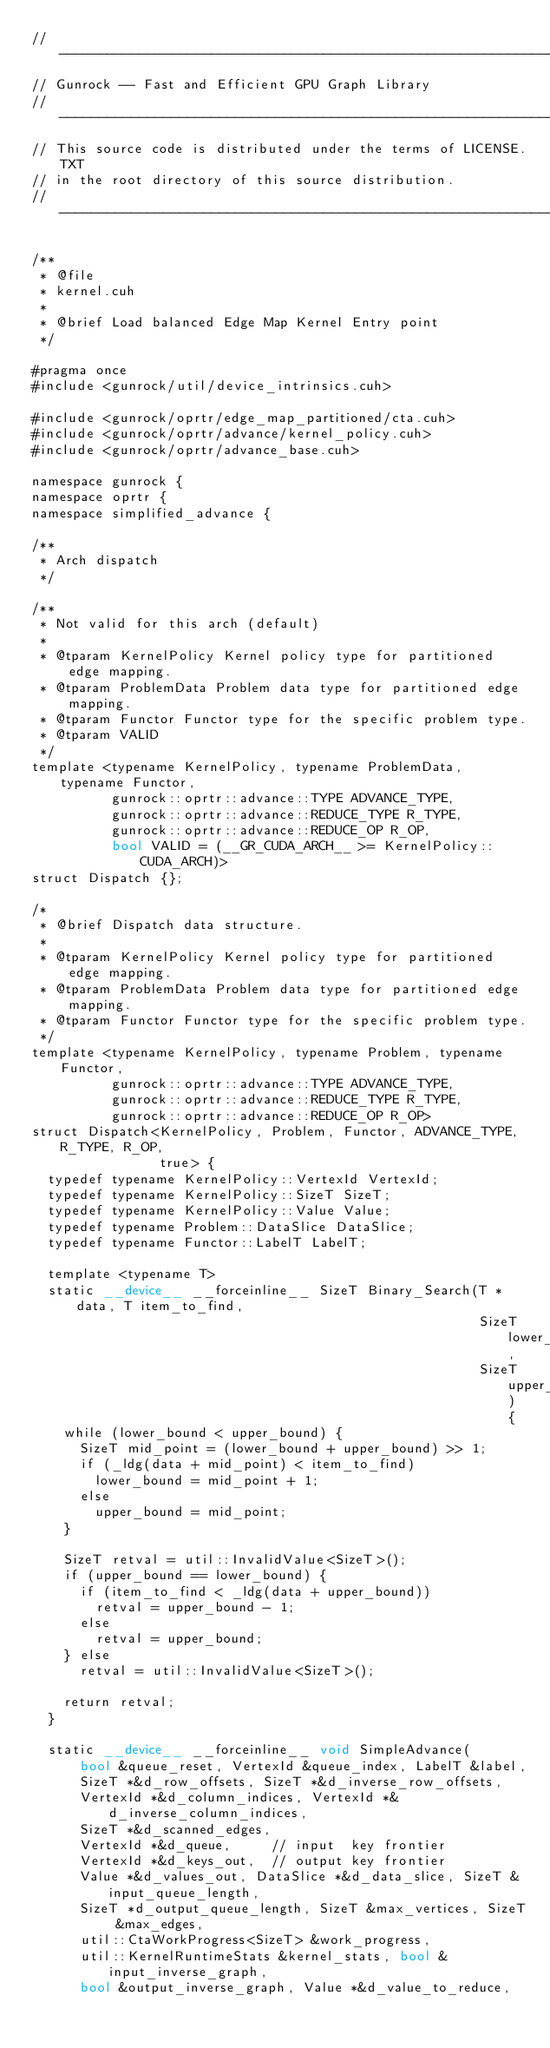<code> <loc_0><loc_0><loc_500><loc_500><_Cuda_>// ----------------------------------------------------------------
// Gunrock -- Fast and Efficient GPU Graph Library
// ----------------------------------------------------------------
// This source code is distributed under the terms of LICENSE.TXT
// in the root directory of this source distribution.
// ----------------------------------------------------------------

/**
 * @file
 * kernel.cuh
 *
 * @brief Load balanced Edge Map Kernel Entry point
 */

#pragma once
#include <gunrock/util/device_intrinsics.cuh>

#include <gunrock/oprtr/edge_map_partitioned/cta.cuh>
#include <gunrock/oprtr/advance/kernel_policy.cuh>
#include <gunrock/oprtr/advance_base.cuh>

namespace gunrock {
namespace oprtr {
namespace simplified_advance {

/**
 * Arch dispatch
 */

/**
 * Not valid for this arch (default)
 *
 * @tparam KernelPolicy Kernel policy type for partitioned edge mapping.
 * @tparam ProblemData Problem data type for partitioned edge mapping.
 * @tparam Functor Functor type for the specific problem type.
 * @tparam VALID
 */
template <typename KernelPolicy, typename ProblemData, typename Functor,
          gunrock::oprtr::advance::TYPE ADVANCE_TYPE,
          gunrock::oprtr::advance::REDUCE_TYPE R_TYPE,
          gunrock::oprtr::advance::REDUCE_OP R_OP,
          bool VALID = (__GR_CUDA_ARCH__ >= KernelPolicy::CUDA_ARCH)>
struct Dispatch {};

/*
 * @brief Dispatch data structure.
 *
 * @tparam KernelPolicy Kernel policy type for partitioned edge mapping.
 * @tparam ProblemData Problem data type for partitioned edge mapping.
 * @tparam Functor Functor type for the specific problem type.
 */
template <typename KernelPolicy, typename Problem, typename Functor,
          gunrock::oprtr::advance::TYPE ADVANCE_TYPE,
          gunrock::oprtr::advance::REDUCE_TYPE R_TYPE,
          gunrock::oprtr::advance::REDUCE_OP R_OP>
struct Dispatch<KernelPolicy, Problem, Functor, ADVANCE_TYPE, R_TYPE, R_OP,
                true> {
  typedef typename KernelPolicy::VertexId VertexId;
  typedef typename KernelPolicy::SizeT SizeT;
  typedef typename KernelPolicy::Value Value;
  typedef typename Problem::DataSlice DataSlice;
  typedef typename Functor::LabelT LabelT;

  template <typename T>
  static __device__ __forceinline__ SizeT Binary_Search(T *data, T item_to_find,
                                                        SizeT lower_bound,
                                                        SizeT upper_bound) {
    while (lower_bound < upper_bound) {
      SizeT mid_point = (lower_bound + upper_bound) >> 1;
      if (_ldg(data + mid_point) < item_to_find)
        lower_bound = mid_point + 1;
      else
        upper_bound = mid_point;
    }

    SizeT retval = util::InvalidValue<SizeT>();
    if (upper_bound == lower_bound) {
      if (item_to_find < _ldg(data + upper_bound))
        retval = upper_bound - 1;
      else
        retval = upper_bound;
    } else
      retval = util::InvalidValue<SizeT>();

    return retval;
  }

  static __device__ __forceinline__ void SimpleAdvance(
      bool &queue_reset, VertexId &queue_index, LabelT &label,
      SizeT *&d_row_offsets, SizeT *&d_inverse_row_offsets,
      VertexId *&d_column_indices, VertexId *&d_inverse_column_indices,
      SizeT *&d_scanned_edges,
      VertexId *&d_queue,     // input  key frontier
      VertexId *&d_keys_out,  // output key frontier
      Value *&d_values_out, DataSlice *&d_data_slice, SizeT &input_queue_length,
      SizeT *d_output_queue_length, SizeT &max_vertices, SizeT &max_edges,
      util::CtaWorkProgress<SizeT> &work_progress,
      util::KernelRuntimeStats &kernel_stats, bool &input_inverse_graph,
      bool &output_inverse_graph, Value *&d_value_to_reduce,</code> 